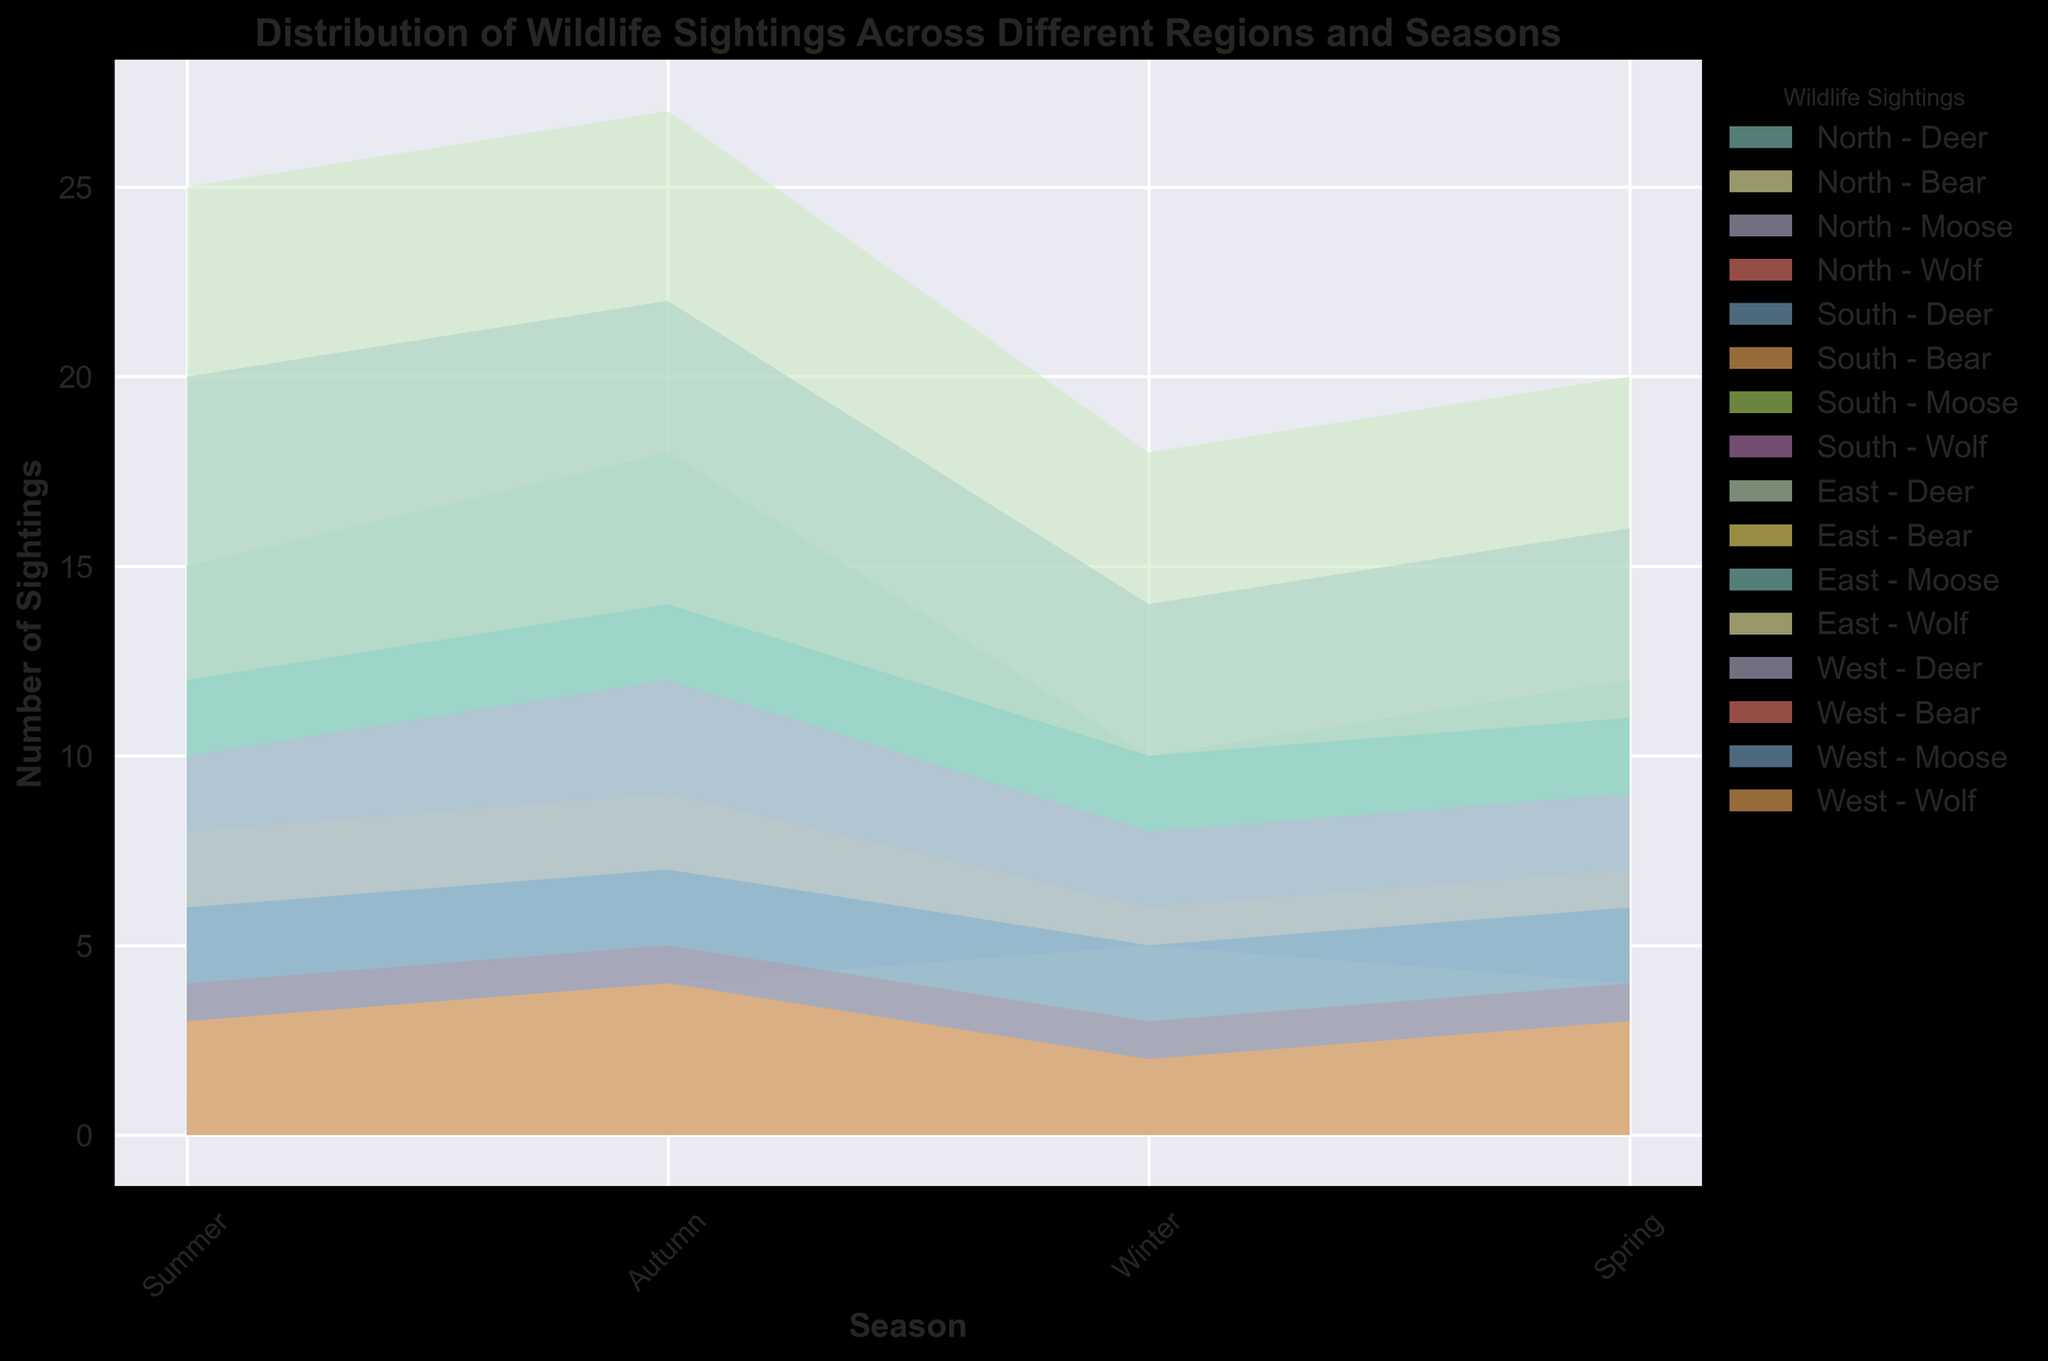What are the total number of deer sightings in the North region across all seasons? To find the total number of deer sightings in the North region, sum the deer sightings for each season: Summer (15) + Autumn (18) + Winter (10) + Spring (12) = 15 + 18 + 10 + 12 = 55
Answer: 55 Which region has the highest number of bear sightings in summer? Compare the bear sightings in summer for all regions: North (5), South (3), East (8), West (4). The East region has the highest bear sightings in summer.
Answer: East How do the wolf sightings in winter compare between the South and North regions? Look at wolf sightings in winter: South (1) and North (5). The North region has more wolf sightings in winter compared to the South region (5 is greater than 1).
Answer: North What is the average number of moose sightings across all regions in autumn? Sum the moose sightings in autumn across all regions and divide by the number of regions. North (12) + South (7) + East (14) + West (7) = 12 + 7 + 14 + 7 = 40. Average = 40 / 4 = 10
Answer: 10 In which season does the East region have the highest number of wildlife sightings? Compare the total sightings (sum of all animals) in East for each season. Summer: 25 (Deer) + 8 (Bear) + 12 (Moose) + 3 (Wolf) = 48. Autumn: 27 (Deer) + 9 (Bear) + 14 (Moose) + 4 (Wolf) = 54. Winter: 18 (Deer) + 6 (Bear) + 10 (Moose) + 5 (Wolf) = 39. Spring: 20 (Deer) + 7 (Bear) + 11 (Moose) + 4 (Wolf) = 42. The highest number of sightings is in Autumn (54).
Answer: Autumn Is the difference in deer sightings between summer and winter greater in the South or the West region? Calculate the difference in deer sightings between summer and winter for each region. South: Summer (20) - Winter (14) = 6. West: Summer (10) - Winter (8) = 2. The difference is greater in the South region.
Answer: South Which animal has the highest number of sightings in the Spring season across the North region? Compare the number of sightings for each animal in the Spring in North: Deer (12), Bear (6), Moose (9), Wolf (3). The animal with the highest sightings is Deer (12).
Answer: Deer What is the combined total of wolf sightings in the East region across Winter and Spring seasons? Add the wolf sightings in Winter and Spring for the East region: Winter (5) + Spring (4) = 5 + 4 = 9
Answer: 9 How does the number of bear sightings in Autumn compare between the North and West regions? Compare bear sightings in Autumn between North and West regions: North (7), West (5). The North region has more bear sightings in Autumn than the West (7 is greater than 5).
Answer: North 